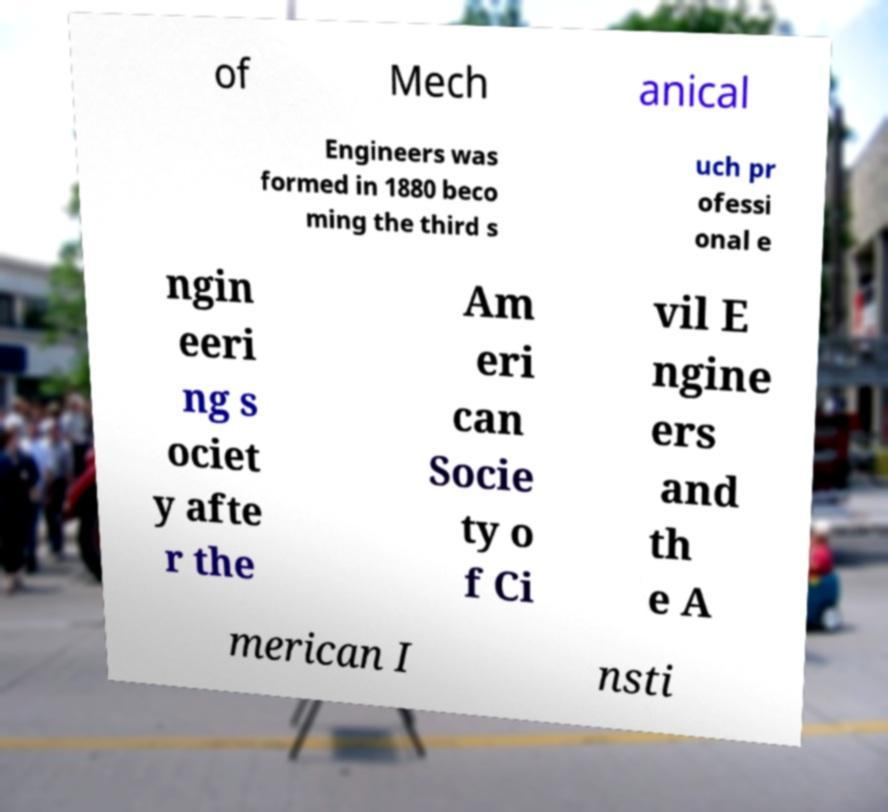Please read and relay the text visible in this image. What does it say? of Mech anical Engineers was formed in 1880 beco ming the third s uch pr ofessi onal e ngin eeri ng s ociet y afte r the Am eri can Socie ty o f Ci vil E ngine ers and th e A merican I nsti 